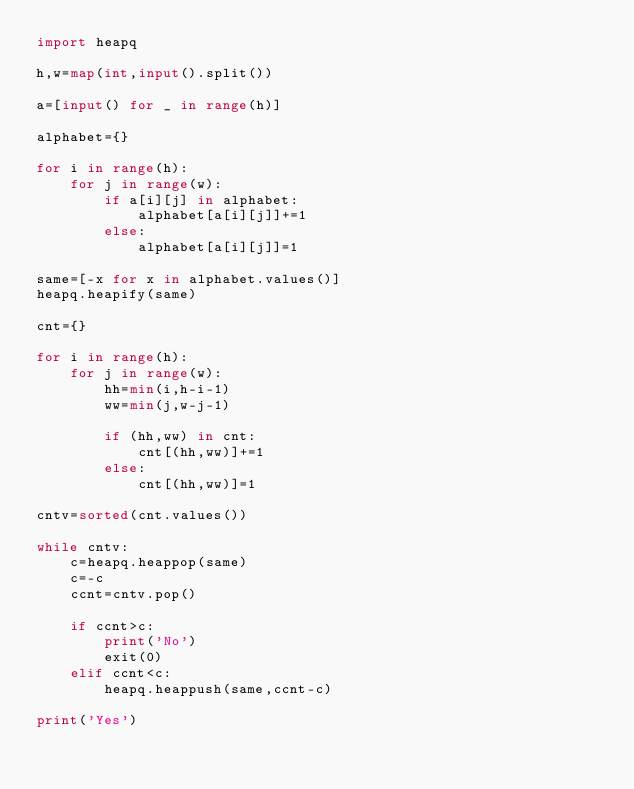Convert code to text. <code><loc_0><loc_0><loc_500><loc_500><_Python_>import heapq

h,w=map(int,input().split())

a=[input() for _ in range(h)]

alphabet={}

for i in range(h):
    for j in range(w):
        if a[i][j] in alphabet:
            alphabet[a[i][j]]+=1
        else:
            alphabet[a[i][j]]=1

same=[-x for x in alphabet.values()]
heapq.heapify(same)

cnt={}

for i in range(h):
    for j in range(w):
        hh=min(i,h-i-1)
        ww=min(j,w-j-1)

        if (hh,ww) in cnt:
            cnt[(hh,ww)]+=1
        else:
            cnt[(hh,ww)]=1

cntv=sorted(cnt.values())

while cntv:
    c=heapq.heappop(same)
    c=-c
    ccnt=cntv.pop()

    if ccnt>c:
        print('No')
        exit(0)
    elif ccnt<c:
        heapq.heappush(same,ccnt-c)

print('Yes')</code> 